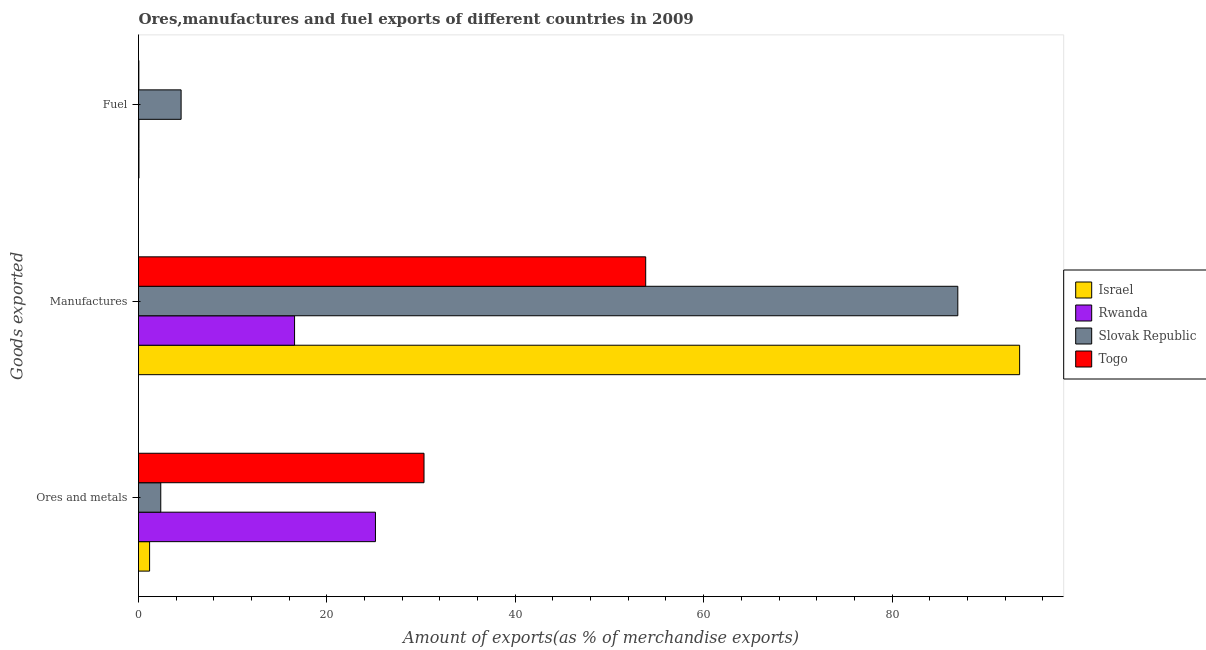How many different coloured bars are there?
Offer a very short reply. 4. How many groups of bars are there?
Your answer should be compact. 3. How many bars are there on the 3rd tick from the bottom?
Ensure brevity in your answer.  4. What is the label of the 2nd group of bars from the top?
Provide a succinct answer. Manufactures. What is the percentage of ores and metals exports in Togo?
Your response must be concise. 30.31. Across all countries, what is the maximum percentage of ores and metals exports?
Offer a very short reply. 30.31. Across all countries, what is the minimum percentage of fuel exports?
Keep it short and to the point. 0.04. In which country was the percentage of ores and metals exports maximum?
Ensure brevity in your answer.  Togo. In which country was the percentage of fuel exports minimum?
Your answer should be very brief. Togo. What is the total percentage of ores and metals exports in the graph?
Offer a very short reply. 59. What is the difference between the percentage of fuel exports in Togo and that in Slovak Republic?
Your answer should be compact. -4.49. What is the difference between the percentage of manufactures exports in Slovak Republic and the percentage of fuel exports in Togo?
Your answer should be compact. 86.95. What is the average percentage of fuel exports per country?
Offer a very short reply. 1.16. What is the difference between the percentage of fuel exports and percentage of ores and metals exports in Slovak Republic?
Provide a succinct answer. 2.16. What is the ratio of the percentage of manufactures exports in Israel to that in Rwanda?
Offer a very short reply. 5.65. Is the difference between the percentage of fuel exports in Slovak Republic and Rwanda greater than the difference between the percentage of ores and metals exports in Slovak Republic and Rwanda?
Your answer should be compact. Yes. What is the difference between the highest and the second highest percentage of ores and metals exports?
Give a very brief answer. 5.15. What is the difference between the highest and the lowest percentage of manufactures exports?
Ensure brevity in your answer.  76.98. Is the sum of the percentage of ores and metals exports in Slovak Republic and Togo greater than the maximum percentage of fuel exports across all countries?
Offer a terse response. Yes. What does the 2nd bar from the top in Manufactures represents?
Ensure brevity in your answer.  Slovak Republic. What does the 2nd bar from the bottom in Ores and metals represents?
Provide a succinct answer. Rwanda. Is it the case that in every country, the sum of the percentage of ores and metals exports and percentage of manufactures exports is greater than the percentage of fuel exports?
Your response must be concise. Yes. How many bars are there?
Provide a succinct answer. 12. How many countries are there in the graph?
Your response must be concise. 4. Are the values on the major ticks of X-axis written in scientific E-notation?
Make the answer very short. No. Where does the legend appear in the graph?
Give a very brief answer. Center right. How many legend labels are there?
Give a very brief answer. 4. How are the legend labels stacked?
Your response must be concise. Vertical. What is the title of the graph?
Offer a terse response. Ores,manufactures and fuel exports of different countries in 2009. Does "Uganda" appear as one of the legend labels in the graph?
Keep it short and to the point. No. What is the label or title of the X-axis?
Keep it short and to the point. Amount of exports(as % of merchandise exports). What is the label or title of the Y-axis?
Provide a succinct answer. Goods exported. What is the Amount of exports(as % of merchandise exports) in Israel in Ores and metals?
Keep it short and to the point. 1.18. What is the Amount of exports(as % of merchandise exports) of Rwanda in Ores and metals?
Make the answer very short. 25.16. What is the Amount of exports(as % of merchandise exports) of Slovak Republic in Ores and metals?
Give a very brief answer. 2.36. What is the Amount of exports(as % of merchandise exports) of Togo in Ores and metals?
Your response must be concise. 30.31. What is the Amount of exports(as % of merchandise exports) in Israel in Manufactures?
Provide a short and direct response. 93.54. What is the Amount of exports(as % of merchandise exports) in Rwanda in Manufactures?
Provide a short and direct response. 16.57. What is the Amount of exports(as % of merchandise exports) of Slovak Republic in Manufactures?
Ensure brevity in your answer.  86.98. What is the Amount of exports(as % of merchandise exports) of Togo in Manufactures?
Keep it short and to the point. 53.85. What is the Amount of exports(as % of merchandise exports) in Israel in Fuel?
Keep it short and to the point. 0.05. What is the Amount of exports(as % of merchandise exports) of Rwanda in Fuel?
Provide a short and direct response. 0.05. What is the Amount of exports(as % of merchandise exports) of Slovak Republic in Fuel?
Your answer should be compact. 4.52. What is the Amount of exports(as % of merchandise exports) in Togo in Fuel?
Keep it short and to the point. 0.04. Across all Goods exported, what is the maximum Amount of exports(as % of merchandise exports) in Israel?
Provide a succinct answer. 93.54. Across all Goods exported, what is the maximum Amount of exports(as % of merchandise exports) in Rwanda?
Provide a succinct answer. 25.16. Across all Goods exported, what is the maximum Amount of exports(as % of merchandise exports) of Slovak Republic?
Provide a succinct answer. 86.98. Across all Goods exported, what is the maximum Amount of exports(as % of merchandise exports) in Togo?
Your answer should be compact. 53.85. Across all Goods exported, what is the minimum Amount of exports(as % of merchandise exports) of Israel?
Your answer should be very brief. 0.05. Across all Goods exported, what is the minimum Amount of exports(as % of merchandise exports) in Rwanda?
Provide a succinct answer. 0.05. Across all Goods exported, what is the minimum Amount of exports(as % of merchandise exports) in Slovak Republic?
Offer a very short reply. 2.36. Across all Goods exported, what is the minimum Amount of exports(as % of merchandise exports) in Togo?
Offer a terse response. 0.04. What is the total Amount of exports(as % of merchandise exports) of Israel in the graph?
Your answer should be very brief. 94.77. What is the total Amount of exports(as % of merchandise exports) in Rwanda in the graph?
Offer a terse response. 41.77. What is the total Amount of exports(as % of merchandise exports) of Slovak Republic in the graph?
Offer a terse response. 93.87. What is the total Amount of exports(as % of merchandise exports) in Togo in the graph?
Make the answer very short. 84.19. What is the difference between the Amount of exports(as % of merchandise exports) in Israel in Ores and metals and that in Manufactures?
Keep it short and to the point. -92.37. What is the difference between the Amount of exports(as % of merchandise exports) of Rwanda in Ores and metals and that in Manufactures?
Provide a succinct answer. 8.59. What is the difference between the Amount of exports(as % of merchandise exports) of Slovak Republic in Ores and metals and that in Manufactures?
Provide a succinct answer. -84.62. What is the difference between the Amount of exports(as % of merchandise exports) in Togo in Ores and metals and that in Manufactures?
Give a very brief answer. -23.54. What is the difference between the Amount of exports(as % of merchandise exports) in Israel in Ores and metals and that in Fuel?
Keep it short and to the point. 1.13. What is the difference between the Amount of exports(as % of merchandise exports) of Rwanda in Ores and metals and that in Fuel?
Provide a succinct answer. 25.11. What is the difference between the Amount of exports(as % of merchandise exports) of Slovak Republic in Ores and metals and that in Fuel?
Give a very brief answer. -2.16. What is the difference between the Amount of exports(as % of merchandise exports) in Togo in Ores and metals and that in Fuel?
Offer a terse response. 30.27. What is the difference between the Amount of exports(as % of merchandise exports) in Israel in Manufactures and that in Fuel?
Your answer should be compact. 93.5. What is the difference between the Amount of exports(as % of merchandise exports) in Rwanda in Manufactures and that in Fuel?
Your response must be concise. 16.52. What is the difference between the Amount of exports(as % of merchandise exports) in Slovak Republic in Manufactures and that in Fuel?
Ensure brevity in your answer.  82.46. What is the difference between the Amount of exports(as % of merchandise exports) in Togo in Manufactures and that in Fuel?
Provide a short and direct response. 53.81. What is the difference between the Amount of exports(as % of merchandise exports) in Israel in Ores and metals and the Amount of exports(as % of merchandise exports) in Rwanda in Manufactures?
Your answer should be compact. -15.39. What is the difference between the Amount of exports(as % of merchandise exports) of Israel in Ores and metals and the Amount of exports(as % of merchandise exports) of Slovak Republic in Manufactures?
Ensure brevity in your answer.  -85.8. What is the difference between the Amount of exports(as % of merchandise exports) in Israel in Ores and metals and the Amount of exports(as % of merchandise exports) in Togo in Manufactures?
Provide a short and direct response. -52.67. What is the difference between the Amount of exports(as % of merchandise exports) in Rwanda in Ores and metals and the Amount of exports(as % of merchandise exports) in Slovak Republic in Manufactures?
Ensure brevity in your answer.  -61.83. What is the difference between the Amount of exports(as % of merchandise exports) in Rwanda in Ores and metals and the Amount of exports(as % of merchandise exports) in Togo in Manufactures?
Provide a succinct answer. -28.69. What is the difference between the Amount of exports(as % of merchandise exports) in Slovak Republic in Ores and metals and the Amount of exports(as % of merchandise exports) in Togo in Manufactures?
Make the answer very short. -51.48. What is the difference between the Amount of exports(as % of merchandise exports) of Israel in Ores and metals and the Amount of exports(as % of merchandise exports) of Rwanda in Fuel?
Keep it short and to the point. 1.13. What is the difference between the Amount of exports(as % of merchandise exports) in Israel in Ores and metals and the Amount of exports(as % of merchandise exports) in Slovak Republic in Fuel?
Offer a very short reply. -3.35. What is the difference between the Amount of exports(as % of merchandise exports) of Israel in Ores and metals and the Amount of exports(as % of merchandise exports) of Togo in Fuel?
Offer a terse response. 1.14. What is the difference between the Amount of exports(as % of merchandise exports) of Rwanda in Ores and metals and the Amount of exports(as % of merchandise exports) of Slovak Republic in Fuel?
Your response must be concise. 20.63. What is the difference between the Amount of exports(as % of merchandise exports) in Rwanda in Ores and metals and the Amount of exports(as % of merchandise exports) in Togo in Fuel?
Provide a short and direct response. 25.12. What is the difference between the Amount of exports(as % of merchandise exports) of Slovak Republic in Ores and metals and the Amount of exports(as % of merchandise exports) of Togo in Fuel?
Provide a succinct answer. 2.33. What is the difference between the Amount of exports(as % of merchandise exports) in Israel in Manufactures and the Amount of exports(as % of merchandise exports) in Rwanda in Fuel?
Your answer should be compact. 93.5. What is the difference between the Amount of exports(as % of merchandise exports) of Israel in Manufactures and the Amount of exports(as % of merchandise exports) of Slovak Republic in Fuel?
Your response must be concise. 89.02. What is the difference between the Amount of exports(as % of merchandise exports) of Israel in Manufactures and the Amount of exports(as % of merchandise exports) of Togo in Fuel?
Your answer should be compact. 93.51. What is the difference between the Amount of exports(as % of merchandise exports) of Rwanda in Manufactures and the Amount of exports(as % of merchandise exports) of Slovak Republic in Fuel?
Offer a very short reply. 12.05. What is the difference between the Amount of exports(as % of merchandise exports) in Rwanda in Manufactures and the Amount of exports(as % of merchandise exports) in Togo in Fuel?
Provide a short and direct response. 16.53. What is the difference between the Amount of exports(as % of merchandise exports) in Slovak Republic in Manufactures and the Amount of exports(as % of merchandise exports) in Togo in Fuel?
Provide a succinct answer. 86.95. What is the average Amount of exports(as % of merchandise exports) of Israel per Goods exported?
Your answer should be compact. 31.59. What is the average Amount of exports(as % of merchandise exports) of Rwanda per Goods exported?
Offer a terse response. 13.92. What is the average Amount of exports(as % of merchandise exports) in Slovak Republic per Goods exported?
Ensure brevity in your answer.  31.29. What is the average Amount of exports(as % of merchandise exports) of Togo per Goods exported?
Offer a very short reply. 28.06. What is the difference between the Amount of exports(as % of merchandise exports) in Israel and Amount of exports(as % of merchandise exports) in Rwanda in Ores and metals?
Your response must be concise. -23.98. What is the difference between the Amount of exports(as % of merchandise exports) of Israel and Amount of exports(as % of merchandise exports) of Slovak Republic in Ores and metals?
Give a very brief answer. -1.19. What is the difference between the Amount of exports(as % of merchandise exports) of Israel and Amount of exports(as % of merchandise exports) of Togo in Ores and metals?
Offer a terse response. -29.13. What is the difference between the Amount of exports(as % of merchandise exports) of Rwanda and Amount of exports(as % of merchandise exports) of Slovak Republic in Ores and metals?
Your response must be concise. 22.79. What is the difference between the Amount of exports(as % of merchandise exports) of Rwanda and Amount of exports(as % of merchandise exports) of Togo in Ores and metals?
Ensure brevity in your answer.  -5.15. What is the difference between the Amount of exports(as % of merchandise exports) of Slovak Republic and Amount of exports(as % of merchandise exports) of Togo in Ores and metals?
Offer a very short reply. -27.95. What is the difference between the Amount of exports(as % of merchandise exports) in Israel and Amount of exports(as % of merchandise exports) in Rwanda in Manufactures?
Give a very brief answer. 76.98. What is the difference between the Amount of exports(as % of merchandise exports) in Israel and Amount of exports(as % of merchandise exports) in Slovak Republic in Manufactures?
Offer a very short reply. 6.56. What is the difference between the Amount of exports(as % of merchandise exports) in Israel and Amount of exports(as % of merchandise exports) in Togo in Manufactures?
Provide a succinct answer. 39.7. What is the difference between the Amount of exports(as % of merchandise exports) of Rwanda and Amount of exports(as % of merchandise exports) of Slovak Republic in Manufactures?
Your answer should be very brief. -70.41. What is the difference between the Amount of exports(as % of merchandise exports) of Rwanda and Amount of exports(as % of merchandise exports) of Togo in Manufactures?
Provide a succinct answer. -37.28. What is the difference between the Amount of exports(as % of merchandise exports) of Slovak Republic and Amount of exports(as % of merchandise exports) of Togo in Manufactures?
Offer a very short reply. 33.13. What is the difference between the Amount of exports(as % of merchandise exports) of Israel and Amount of exports(as % of merchandise exports) of Slovak Republic in Fuel?
Give a very brief answer. -4.48. What is the difference between the Amount of exports(as % of merchandise exports) of Israel and Amount of exports(as % of merchandise exports) of Togo in Fuel?
Provide a succinct answer. 0.01. What is the difference between the Amount of exports(as % of merchandise exports) of Rwanda and Amount of exports(as % of merchandise exports) of Slovak Republic in Fuel?
Your response must be concise. -4.48. What is the difference between the Amount of exports(as % of merchandise exports) in Rwanda and Amount of exports(as % of merchandise exports) in Togo in Fuel?
Your response must be concise. 0.01. What is the difference between the Amount of exports(as % of merchandise exports) in Slovak Republic and Amount of exports(as % of merchandise exports) in Togo in Fuel?
Provide a succinct answer. 4.49. What is the ratio of the Amount of exports(as % of merchandise exports) of Israel in Ores and metals to that in Manufactures?
Make the answer very short. 0.01. What is the ratio of the Amount of exports(as % of merchandise exports) of Rwanda in Ores and metals to that in Manufactures?
Your answer should be very brief. 1.52. What is the ratio of the Amount of exports(as % of merchandise exports) of Slovak Republic in Ores and metals to that in Manufactures?
Keep it short and to the point. 0.03. What is the ratio of the Amount of exports(as % of merchandise exports) of Togo in Ores and metals to that in Manufactures?
Give a very brief answer. 0.56. What is the ratio of the Amount of exports(as % of merchandise exports) in Israel in Ores and metals to that in Fuel?
Provide a succinct answer. 25.04. What is the ratio of the Amount of exports(as % of merchandise exports) in Rwanda in Ores and metals to that in Fuel?
Provide a short and direct response. 538.78. What is the ratio of the Amount of exports(as % of merchandise exports) of Slovak Republic in Ores and metals to that in Fuel?
Ensure brevity in your answer.  0.52. What is the ratio of the Amount of exports(as % of merchandise exports) in Togo in Ores and metals to that in Fuel?
Ensure brevity in your answer.  846.45. What is the ratio of the Amount of exports(as % of merchandise exports) of Israel in Manufactures to that in Fuel?
Make the answer very short. 1991.33. What is the ratio of the Amount of exports(as % of merchandise exports) in Rwanda in Manufactures to that in Fuel?
Ensure brevity in your answer.  354.85. What is the ratio of the Amount of exports(as % of merchandise exports) of Slovak Republic in Manufactures to that in Fuel?
Your answer should be compact. 19.23. What is the ratio of the Amount of exports(as % of merchandise exports) in Togo in Manufactures to that in Fuel?
Keep it short and to the point. 1503.73. What is the difference between the highest and the second highest Amount of exports(as % of merchandise exports) in Israel?
Make the answer very short. 92.37. What is the difference between the highest and the second highest Amount of exports(as % of merchandise exports) of Rwanda?
Keep it short and to the point. 8.59. What is the difference between the highest and the second highest Amount of exports(as % of merchandise exports) in Slovak Republic?
Give a very brief answer. 82.46. What is the difference between the highest and the second highest Amount of exports(as % of merchandise exports) of Togo?
Your answer should be very brief. 23.54. What is the difference between the highest and the lowest Amount of exports(as % of merchandise exports) in Israel?
Your answer should be compact. 93.5. What is the difference between the highest and the lowest Amount of exports(as % of merchandise exports) of Rwanda?
Ensure brevity in your answer.  25.11. What is the difference between the highest and the lowest Amount of exports(as % of merchandise exports) of Slovak Republic?
Your answer should be very brief. 84.62. What is the difference between the highest and the lowest Amount of exports(as % of merchandise exports) in Togo?
Ensure brevity in your answer.  53.81. 